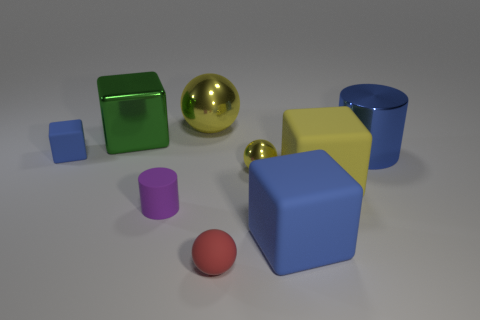Subtract 1 blocks. How many blocks are left? 3 Subtract all balls. How many objects are left? 6 Add 5 shiny cubes. How many shiny cubes exist? 6 Subtract 1 green cubes. How many objects are left? 8 Subtract all purple metal objects. Subtract all tiny purple matte objects. How many objects are left? 8 Add 7 red balls. How many red balls are left? 8 